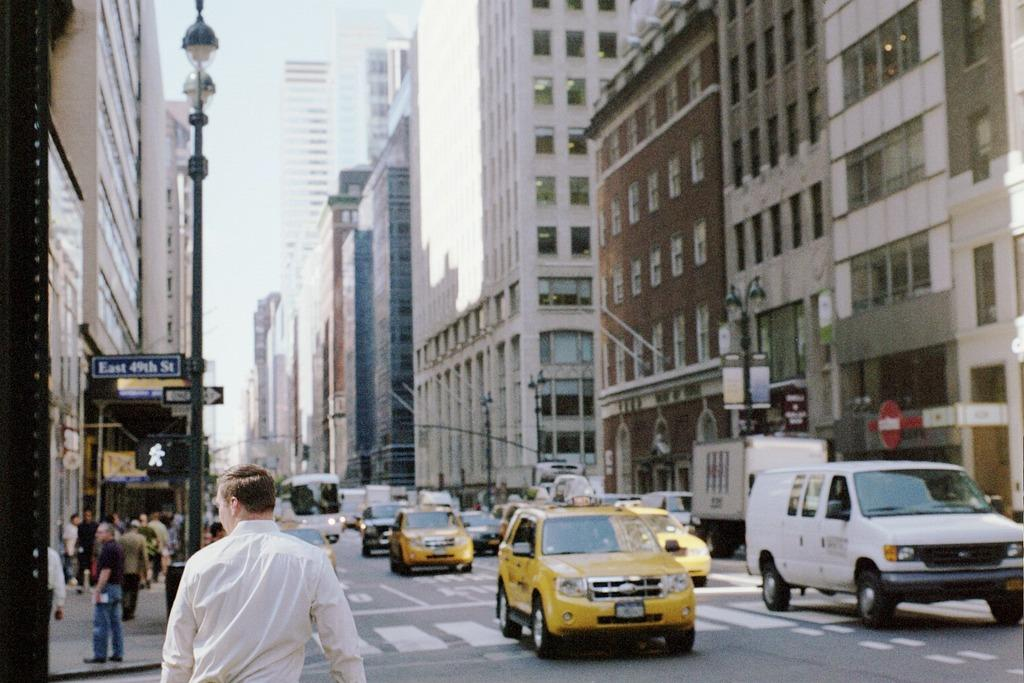<image>
Offer a succinct explanation of the picture presented. Man walking on a street going towards a sign saying East 49th Street. 